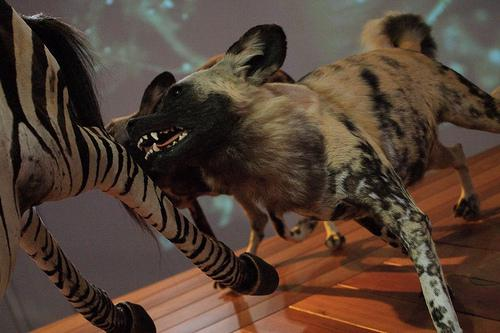Question: what color is the stand?
Choices:
A. Red.
B. Wood.
C. White.
D. Blue.
Answer with the letter. Answer: B Question: what colors are the zebra?
Choices:
A. Black and white.
B. Red and blue.
C. Green and orange.
D. Pink and brown.
Answer with the letter. Answer: A Question: what is the animal to the left?
Choices:
A. A zebra.
B. A cow.
C. A horse.
D. A dog.
Answer with the letter. Answer: A Question: how many animals are here?
Choices:
A. One.
B. Three.
C. Two.
D. Four.
Answer with the letter. Answer: C 